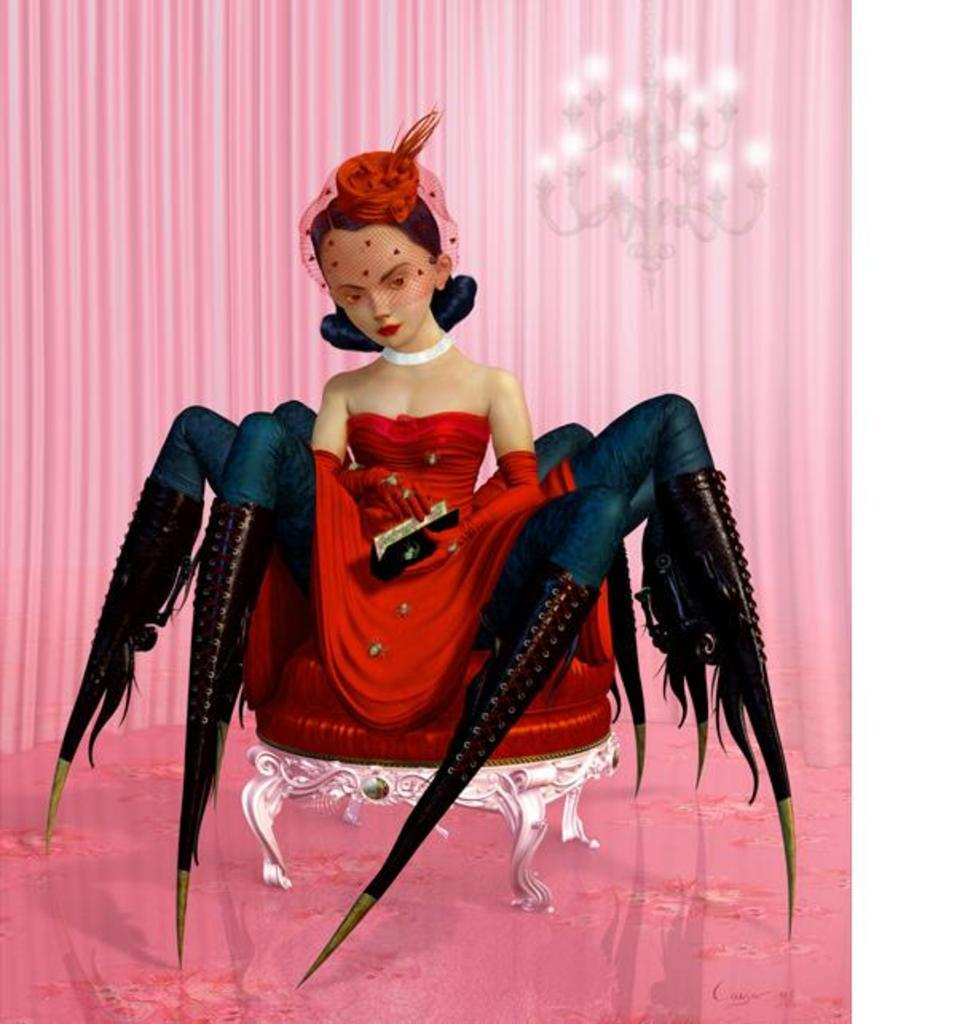What is the main subject in the picture? There is a doll in the picture. Can you describe the doll's appearance? The doll has multiple legs and is wearing a red dress. What other objects can be seen in the picture? There is a lamp in the picture. How is the lamp positioned in relation to the doll? The lamp is behind a pink color curtain. What type of square transport is visible in the image? There is no square transport present in the image. What news event is being reported by the doll in the image? The doll is not reporting any news event in the image; it is simply a doll with multiple legs and a red dress. 